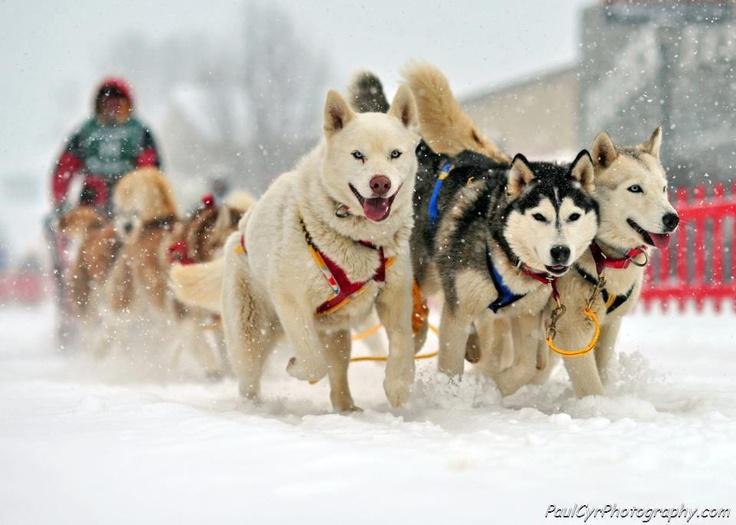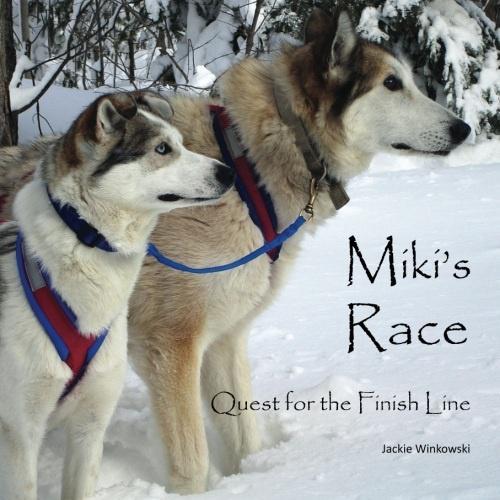The first image is the image on the left, the second image is the image on the right. For the images displayed, is the sentence "There are two walking husky harness together with the one on the right sticking out their tongue." factually correct? Answer yes or no. No. The first image is the image on the left, the second image is the image on the right. Assess this claim about the two images: "One image shows a sled dog team headed forward, and the other image shows two side-by-side dogs, the one on the right with its tongue hanging out.". Correct or not? Answer yes or no. No. 